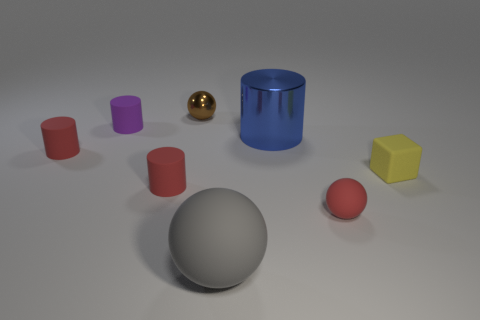Can you describe the lighting in the scene? The scene is lit from above, casting soft shadows directly underneath the objects. The lighting is diffused, creating soft graduations of light and shadow with no harsh lines, which suggests an ambient light source, possibly in a studio setting. 